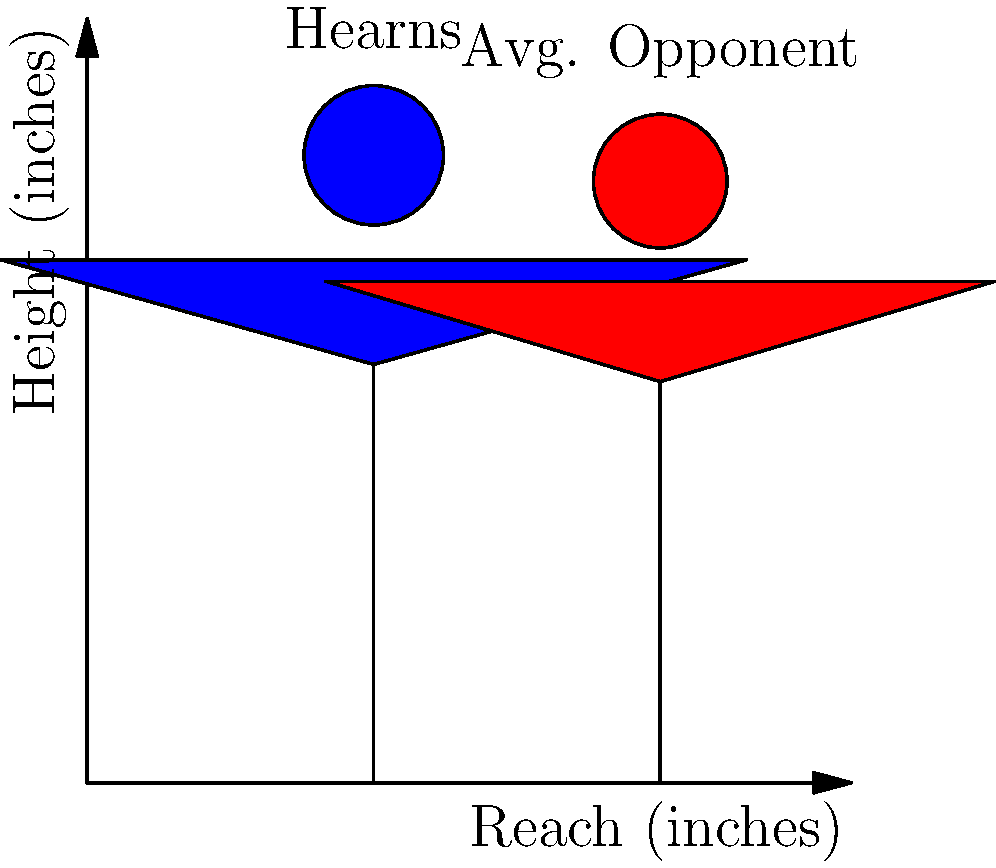Based on the silhouettes representing Thomas Hearns and an average opponent, what was Hearns' approximate reach advantage in inches? To determine Thomas Hearns' reach advantage, we need to follow these steps:

1. Identify Hearns' reach from the blue silhouette:
   Hearns' reach is approximately 78 inches.

2. Identify the average opponent's reach from the red silhouette:
   The average opponent's reach is approximately 70 inches.

3. Calculate the difference:
   $$78 \text{ inches} - 70 \text{ inches} = 8 \text{ inches}$$

Thomas Hearns, known as the "Motor City Cobra," was famous for his exceptional reach, which gave him a significant advantage in the ring. This 8-inch reach advantage allowed Hearns to control the distance in fights, landing punches while staying out of his opponents' range.
Answer: 8 inches 